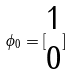Convert formula to latex. <formula><loc_0><loc_0><loc_500><loc_500>\phi _ { 0 } = [ \begin{matrix} 1 \\ 0 \end{matrix} ]</formula> 